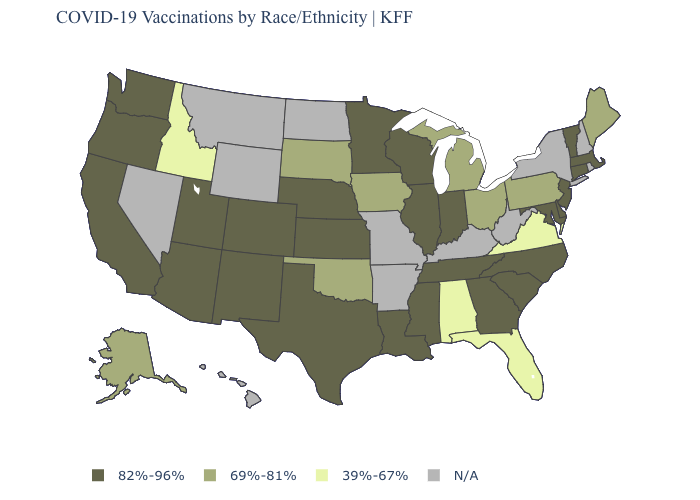Does Ohio have the highest value in the MidWest?
Write a very short answer. No. What is the value of Illinois?
Short answer required. 82%-96%. What is the value of New Hampshire?
Quick response, please. N/A. Among the states that border North Carolina , which have the lowest value?
Keep it brief. Virginia. What is the lowest value in the Northeast?
Concise answer only. 69%-81%. Which states have the highest value in the USA?
Answer briefly. Arizona, California, Colorado, Connecticut, Delaware, Georgia, Illinois, Indiana, Kansas, Louisiana, Maryland, Massachusetts, Minnesota, Mississippi, Nebraska, New Jersey, New Mexico, North Carolina, Oregon, South Carolina, Tennessee, Texas, Utah, Vermont, Washington, Wisconsin. Does Minnesota have the highest value in the MidWest?
Answer briefly. Yes. What is the value of Mississippi?
Give a very brief answer. 82%-96%. Among the states that border New York , which have the lowest value?
Keep it brief. Pennsylvania. Name the states that have a value in the range N/A?
Concise answer only. Arkansas, Hawaii, Kentucky, Missouri, Montana, Nevada, New Hampshire, New York, North Dakota, Rhode Island, West Virginia, Wyoming. What is the value of Florida?
Concise answer only. 39%-67%. Is the legend a continuous bar?
Quick response, please. No. Does the map have missing data?
Concise answer only. Yes. Name the states that have a value in the range N/A?
Be succinct. Arkansas, Hawaii, Kentucky, Missouri, Montana, Nevada, New Hampshire, New York, North Dakota, Rhode Island, West Virginia, Wyoming. 